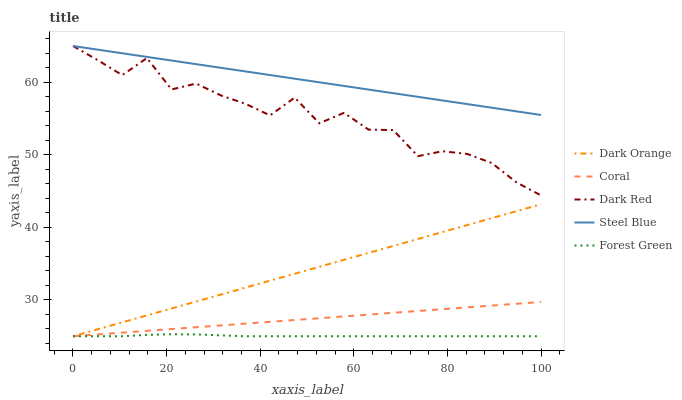Does Forest Green have the minimum area under the curve?
Answer yes or no. Yes. Does Steel Blue have the maximum area under the curve?
Answer yes or no. Yes. Does Dark Orange have the minimum area under the curve?
Answer yes or no. No. Does Dark Orange have the maximum area under the curve?
Answer yes or no. No. Is Coral the smoothest?
Answer yes or no. Yes. Is Dark Red the roughest?
Answer yes or no. Yes. Is Dark Orange the smoothest?
Answer yes or no. No. Is Dark Orange the roughest?
Answer yes or no. No. Does Forest Green have the lowest value?
Answer yes or no. Yes. Does Steel Blue have the lowest value?
Answer yes or no. No. Does Dark Red have the highest value?
Answer yes or no. Yes. Does Dark Orange have the highest value?
Answer yes or no. No. Is Coral less than Dark Red?
Answer yes or no. Yes. Is Dark Red greater than Forest Green?
Answer yes or no. Yes. Does Forest Green intersect Coral?
Answer yes or no. Yes. Is Forest Green less than Coral?
Answer yes or no. No. Is Forest Green greater than Coral?
Answer yes or no. No. Does Coral intersect Dark Red?
Answer yes or no. No. 